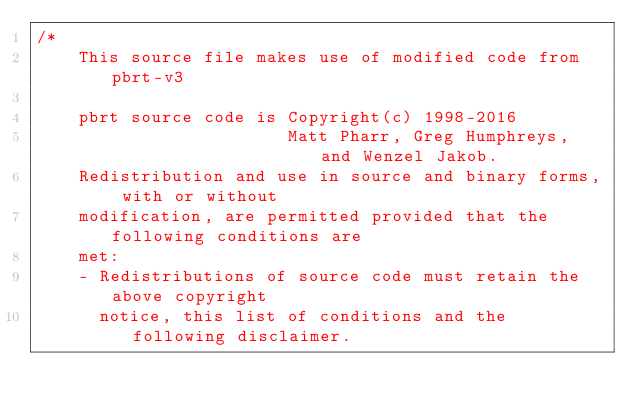<code> <loc_0><loc_0><loc_500><loc_500><_Cuda_>/*
    This source file makes use of modified code from pbrt-v3

    pbrt source code is Copyright(c) 1998-2016
                        Matt Pharr, Greg Humphreys, and Wenzel Jakob.
    Redistribution and use in source and binary forms, with or without
    modification, are permitted provided that the following conditions are
    met:
    - Redistributions of source code must retain the above copyright
      notice, this list of conditions and the following disclaimer.</code> 